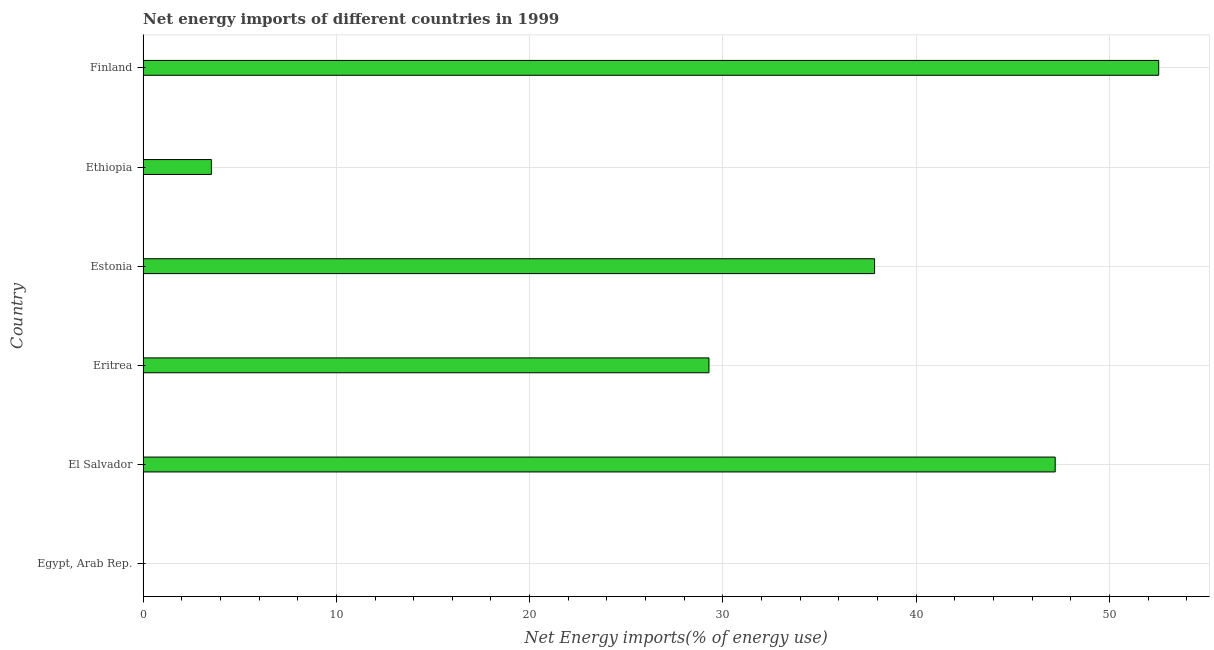What is the title of the graph?
Offer a terse response. Net energy imports of different countries in 1999. What is the label or title of the X-axis?
Provide a succinct answer. Net Energy imports(% of energy use). What is the energy imports in El Salvador?
Give a very brief answer. 47.19. Across all countries, what is the maximum energy imports?
Ensure brevity in your answer.  52.55. Across all countries, what is the minimum energy imports?
Ensure brevity in your answer.  0. What is the sum of the energy imports?
Your response must be concise. 170.4. What is the difference between the energy imports in Estonia and Finland?
Offer a very short reply. -14.7. What is the average energy imports per country?
Offer a very short reply. 28.4. What is the median energy imports?
Provide a succinct answer. 33.56. What is the ratio of the energy imports in Estonia to that in Finland?
Your answer should be very brief. 0.72. Is the energy imports in Eritrea less than that in Estonia?
Provide a short and direct response. Yes. What is the difference between the highest and the second highest energy imports?
Your answer should be compact. 5.36. Is the sum of the energy imports in Estonia and Finland greater than the maximum energy imports across all countries?
Keep it short and to the point. Yes. What is the difference between the highest and the lowest energy imports?
Your response must be concise. 52.55. How many countries are there in the graph?
Offer a terse response. 6. What is the difference between two consecutive major ticks on the X-axis?
Your answer should be compact. 10. What is the Net Energy imports(% of energy use) in Egypt, Arab Rep.?
Offer a terse response. 0. What is the Net Energy imports(% of energy use) in El Salvador?
Ensure brevity in your answer.  47.19. What is the Net Energy imports(% of energy use) in Eritrea?
Your answer should be very brief. 29.28. What is the Net Energy imports(% of energy use) in Estonia?
Offer a terse response. 37.85. What is the Net Energy imports(% of energy use) in Ethiopia?
Offer a very short reply. 3.54. What is the Net Energy imports(% of energy use) of Finland?
Keep it short and to the point. 52.55. What is the difference between the Net Energy imports(% of energy use) in El Salvador and Eritrea?
Make the answer very short. 17.91. What is the difference between the Net Energy imports(% of energy use) in El Salvador and Estonia?
Your response must be concise. 9.35. What is the difference between the Net Energy imports(% of energy use) in El Salvador and Ethiopia?
Your answer should be very brief. 43.66. What is the difference between the Net Energy imports(% of energy use) in El Salvador and Finland?
Your answer should be very brief. -5.36. What is the difference between the Net Energy imports(% of energy use) in Eritrea and Estonia?
Keep it short and to the point. -8.57. What is the difference between the Net Energy imports(% of energy use) in Eritrea and Ethiopia?
Your answer should be compact. 25.74. What is the difference between the Net Energy imports(% of energy use) in Eritrea and Finland?
Provide a succinct answer. -23.27. What is the difference between the Net Energy imports(% of energy use) in Estonia and Ethiopia?
Ensure brevity in your answer.  34.31. What is the difference between the Net Energy imports(% of energy use) in Estonia and Finland?
Your answer should be compact. -14.7. What is the difference between the Net Energy imports(% of energy use) in Ethiopia and Finland?
Give a very brief answer. -49.01. What is the ratio of the Net Energy imports(% of energy use) in El Salvador to that in Eritrea?
Provide a short and direct response. 1.61. What is the ratio of the Net Energy imports(% of energy use) in El Salvador to that in Estonia?
Keep it short and to the point. 1.25. What is the ratio of the Net Energy imports(% of energy use) in El Salvador to that in Ethiopia?
Ensure brevity in your answer.  13.35. What is the ratio of the Net Energy imports(% of energy use) in El Salvador to that in Finland?
Provide a short and direct response. 0.9. What is the ratio of the Net Energy imports(% of energy use) in Eritrea to that in Estonia?
Your answer should be very brief. 0.77. What is the ratio of the Net Energy imports(% of energy use) in Eritrea to that in Ethiopia?
Give a very brief answer. 8.28. What is the ratio of the Net Energy imports(% of energy use) in Eritrea to that in Finland?
Your answer should be compact. 0.56. What is the ratio of the Net Energy imports(% of energy use) in Estonia to that in Ethiopia?
Offer a terse response. 10.71. What is the ratio of the Net Energy imports(% of energy use) in Estonia to that in Finland?
Provide a short and direct response. 0.72. What is the ratio of the Net Energy imports(% of energy use) in Ethiopia to that in Finland?
Provide a short and direct response. 0.07. 